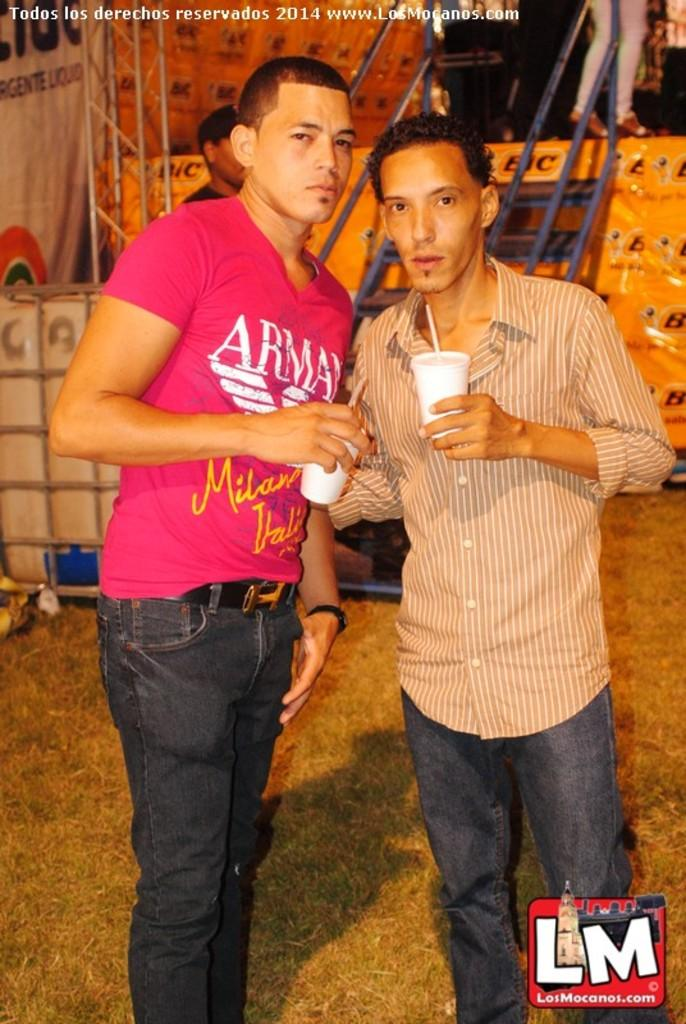What are the two people in the image holding? The two people in the image are holding cups. What can be seen in the background of the image? There are steps and people in the background of the image. Is there any text or marking on the image? Yes, there is a watermark at the top of the image. Are the two people holding cups sisters in the image? There is no information about the relationship between the two people holding cups in the image. What type of apparatus is being used by the people in the image? There is no apparatus visible in the image; the people are simply holding cups. 